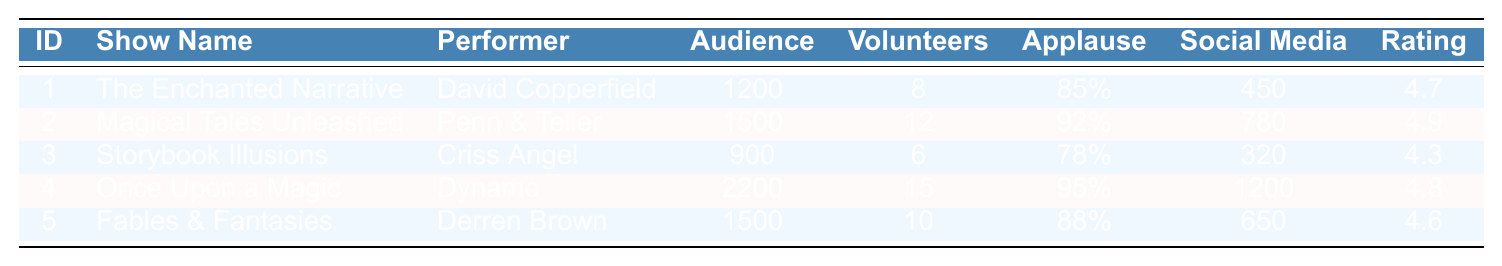What is the total audience size across all shows? The audience sizes for each show are 1200, 1500, 900, 2200, and 1500. Summing these values: 1200 + 1500 + 900 + 2200 + 1500 = 7800.
Answer: 7800 Which show had the highest applause meter rating? The applause meter ratings are 85%, 92%, 78%, 95%, and 88%. The highest rating is 95%, which corresponds to "Once Upon a Magic."
Answer: Once Upon a Magic How many volunteers participated in "Magical Tales Unleashed"? Looking at the table, "Magical Tales Unleashed" has 12 volunteers participating.
Answer: 12 What is the social media mentions count for "Storybook Illusions"? The table shows that "Storybook Illusions" had 320 social media mentions.
Answer: 320 Which performer had the highest post-show survey rating? The post-show survey ratings are 4.7, 4.9, 4.3, 4.8, and 4.6. The highest is 4.9, from the performer Penn & Teller.
Answer: Penn & Teller Is the audience size for "Fables & Fantasies" greater than 1000? The audience size for "Fables & Fantasies" is 1500, which is indeed greater than 1000.
Answer: Yes What is the average audience size across all shows? The audience sizes are 1200, 1500, 900, 2200, and 1500. The total is 7800, and there are 5 shows. Average = 7800 / 5 = 1560.
Answer: 1560 How many shows had a post-show survey rating of 4.7 or higher? The ratings are 4.7, 4.9, 4.3, 4.8, and 4.6. The shows with ratings of 4.7 or higher are "The Enchanted Narrative," "Magical Tales Unleashed," "Once Upon a Magic," and "Fables & Fantasies," totaling 4 shows.
Answer: 4 Which venue had the largest audience, and what was the audience size? The venue with the largest audience is "London Palladium" with an audience size of 2200.
Answer: London Palladium, 2200 If "Once Upon a Magic" had 15 volunteers, what percentage of the audience did that represent? "Once Upon a Magic" had an audience of 2200 and 15 volunteers. To find the percentage, use (15 / 2200) * 100 = 0.68%.
Answer: 0.68% 